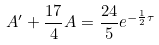<formula> <loc_0><loc_0><loc_500><loc_500>A ^ { \prime } + \frac { 1 7 } { 4 } A = \frac { 2 4 } { 5 } e ^ { - \frac { 1 } { 2 } \tau }</formula> 